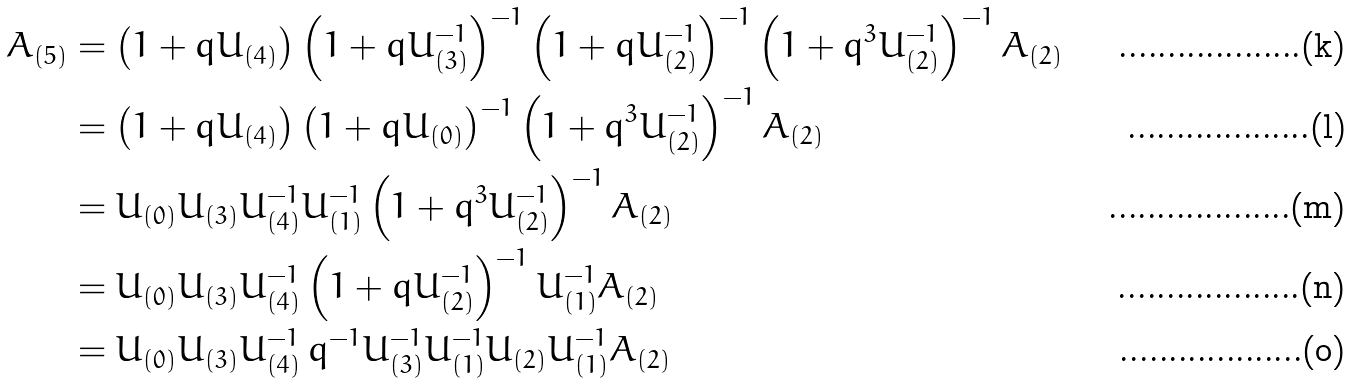Convert formula to latex. <formula><loc_0><loc_0><loc_500><loc_500>A _ { ( 5 ) } & = \left ( 1 + q U _ { ( 4 ) } \right ) \left ( 1 + q U _ { ( 3 ) } ^ { - 1 } \right ) ^ { - 1 } \left ( 1 + q U _ { ( 2 ) } ^ { - 1 } \right ) ^ { - 1 } \left ( 1 + q ^ { 3 } U _ { ( 2 ) } ^ { - 1 } \right ) ^ { - 1 } A _ { ( 2 ) } \\ & = \left ( 1 + q U _ { ( 4 ) } \right ) \left ( 1 + q U _ { ( 0 ) } \right ) ^ { - 1 } \left ( 1 + q ^ { 3 } U _ { ( 2 ) } ^ { - 1 } \right ) ^ { - 1 } A _ { ( 2 ) } \\ & = U _ { ( 0 ) } U _ { ( 3 ) } U _ { ( 4 ) } ^ { - 1 } U _ { ( 1 ) } ^ { - 1 } \left ( 1 + q ^ { 3 } U _ { ( 2 ) } ^ { - 1 } \right ) ^ { - 1 } A _ { ( 2 ) } \\ & = U _ { ( 0 ) } U _ { ( 3 ) } U _ { ( 4 ) } ^ { - 1 } \left ( 1 + q U _ { ( 2 ) } ^ { - 1 } \right ) ^ { - 1 } U _ { ( 1 ) } ^ { - 1 } A _ { ( 2 ) } \\ & = U _ { ( 0 ) } U _ { ( 3 ) } U _ { ( 4 ) } ^ { - 1 } \, q ^ { - 1 } U _ { ( 3 ) } ^ { - 1 } U _ { ( 1 ) } ^ { - 1 } U _ { ( 2 ) } U _ { ( 1 ) } ^ { - 1 } A _ { ( 2 ) }</formula> 